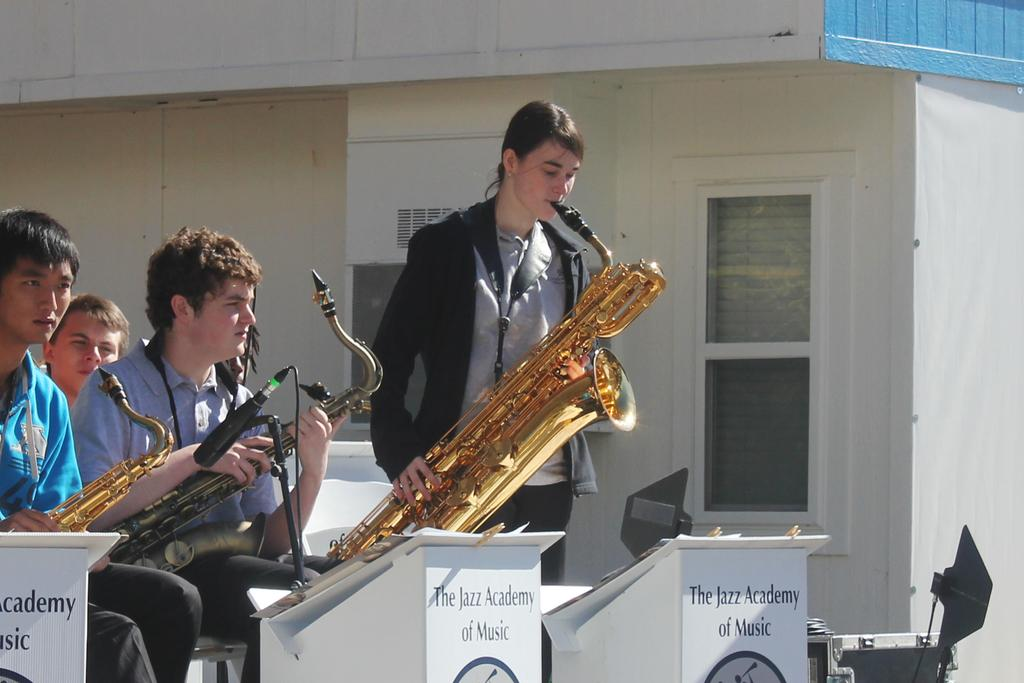<image>
Provide a brief description of the given image. Person playing the saxophone in front of a podium that says The Jazz Academy of Music. 